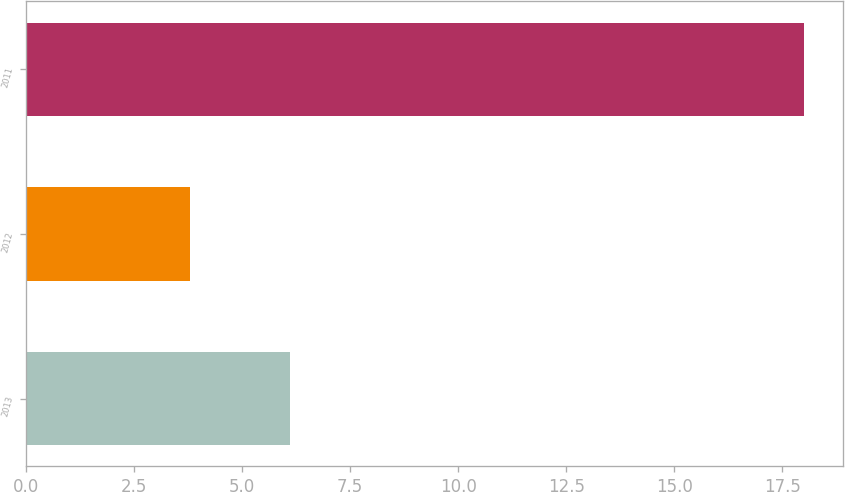<chart> <loc_0><loc_0><loc_500><loc_500><bar_chart><fcel>2013<fcel>2012<fcel>2011<nl><fcel>6.1<fcel>3.8<fcel>18<nl></chart> 